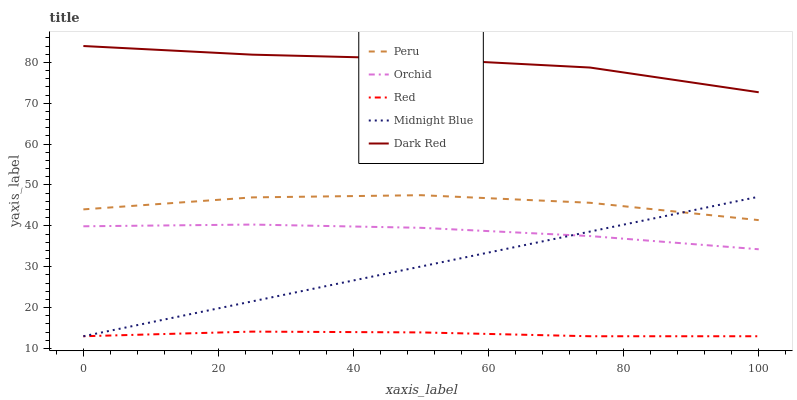Does Red have the minimum area under the curve?
Answer yes or no. Yes. Does Dark Red have the maximum area under the curve?
Answer yes or no. Yes. Does Midnight Blue have the minimum area under the curve?
Answer yes or no. No. Does Midnight Blue have the maximum area under the curve?
Answer yes or no. No. Is Midnight Blue the smoothest?
Answer yes or no. Yes. Is Peru the roughest?
Answer yes or no. Yes. Is Red the smoothest?
Answer yes or no. No. Is Red the roughest?
Answer yes or no. No. Does Midnight Blue have the lowest value?
Answer yes or no. Yes. Does Peru have the lowest value?
Answer yes or no. No. Does Dark Red have the highest value?
Answer yes or no. Yes. Does Midnight Blue have the highest value?
Answer yes or no. No. Is Red less than Dark Red?
Answer yes or no. Yes. Is Peru greater than Red?
Answer yes or no. Yes. Does Midnight Blue intersect Peru?
Answer yes or no. Yes. Is Midnight Blue less than Peru?
Answer yes or no. No. Is Midnight Blue greater than Peru?
Answer yes or no. No. Does Red intersect Dark Red?
Answer yes or no. No. 